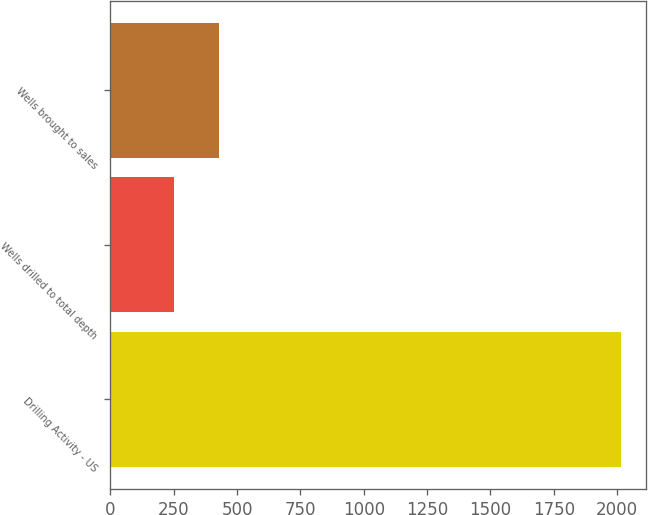<chart> <loc_0><loc_0><loc_500><loc_500><bar_chart><fcel>Drilling Activity - US<fcel>Wells drilled to total depth<fcel>Wells brought to sales<nl><fcel>2015<fcel>251<fcel>427.4<nl></chart> 